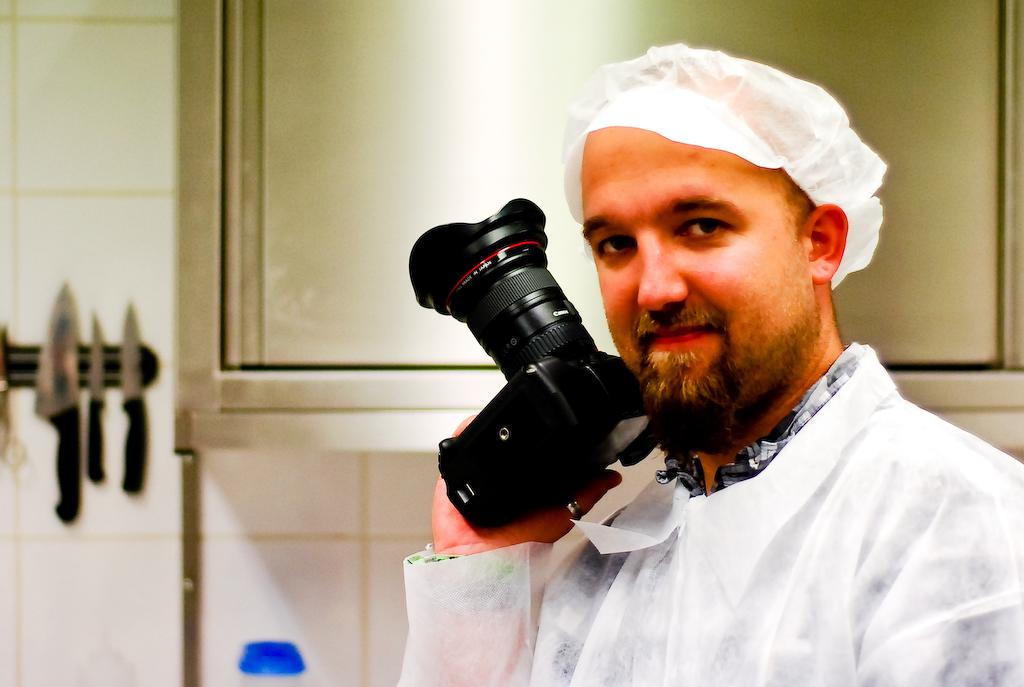Who is the main subject in the image? There is a man in the image. What is the man wearing? The man is wearing a white dress and a white hat. What is the man holding in the image? The man is holding a camera. What can be seen in the background of the image? There is a glass window and a wall in the background of the image. What type of mine is the man exploring in the image? There is no mine present in the image; it features a man wearing a white dress, hat, and holding a camera. Can you see a monkey interacting with the man in the image? There is no monkey present in the image. 